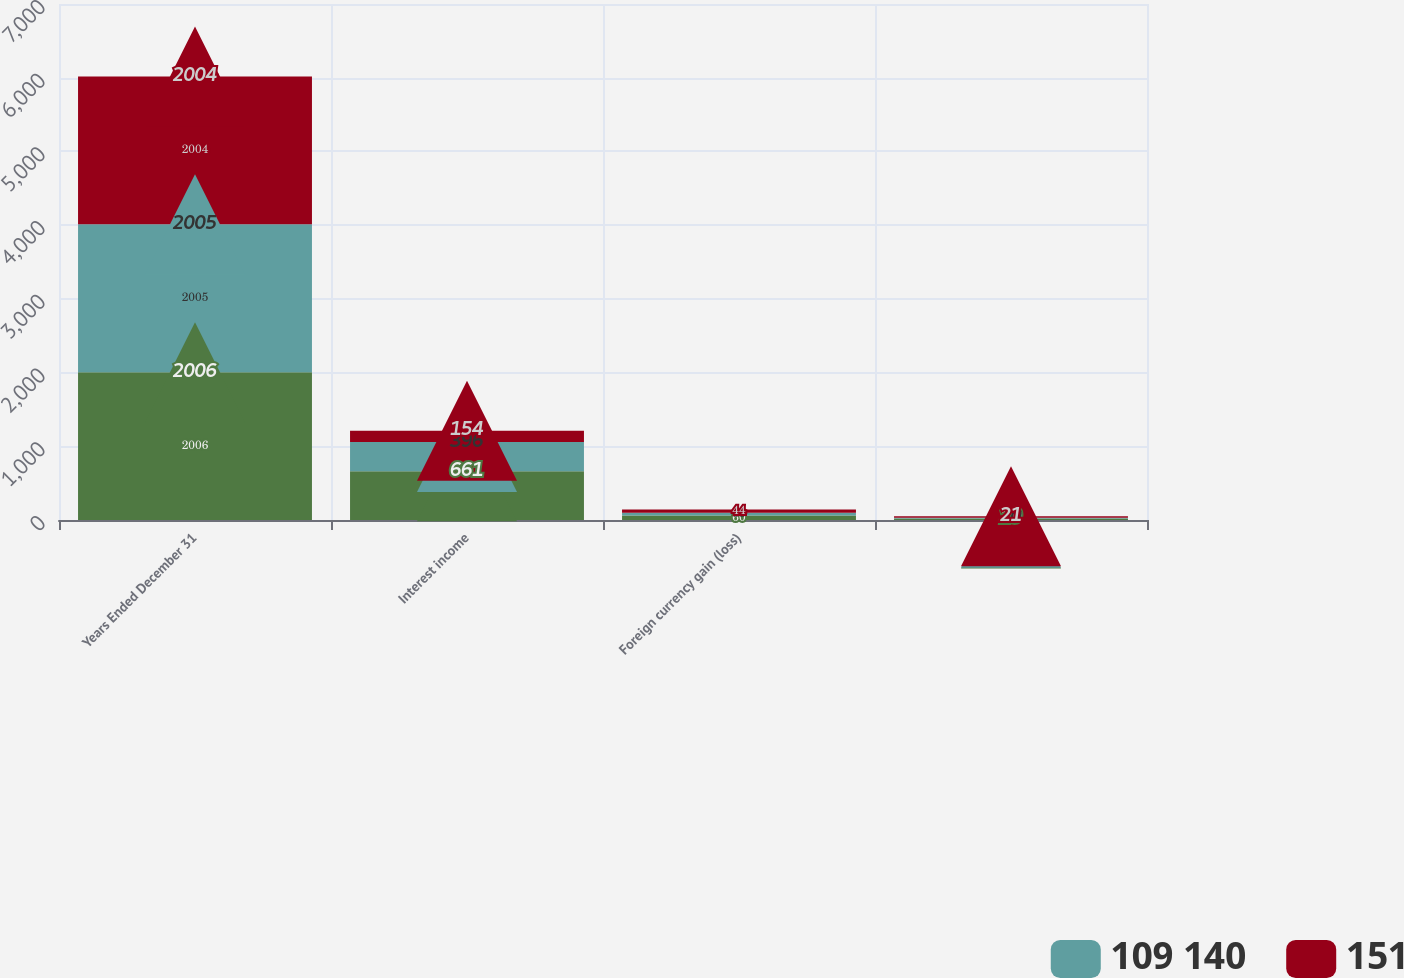Convert chart to OTSL. <chart><loc_0><loc_0><loc_500><loc_500><stacked_bar_chart><ecel><fcel>Years Ended December 31<fcel>Interest income<fcel>Foreign currency gain (loss)<fcel>Other<nl><fcel>nan<fcel>2006<fcel>661<fcel>60<fcel>19<nl><fcel>109 140<fcel>2005<fcel>396<fcel>38<fcel>10<nl><fcel>151<fcel>2004<fcel>154<fcel>44<fcel>21<nl></chart> 